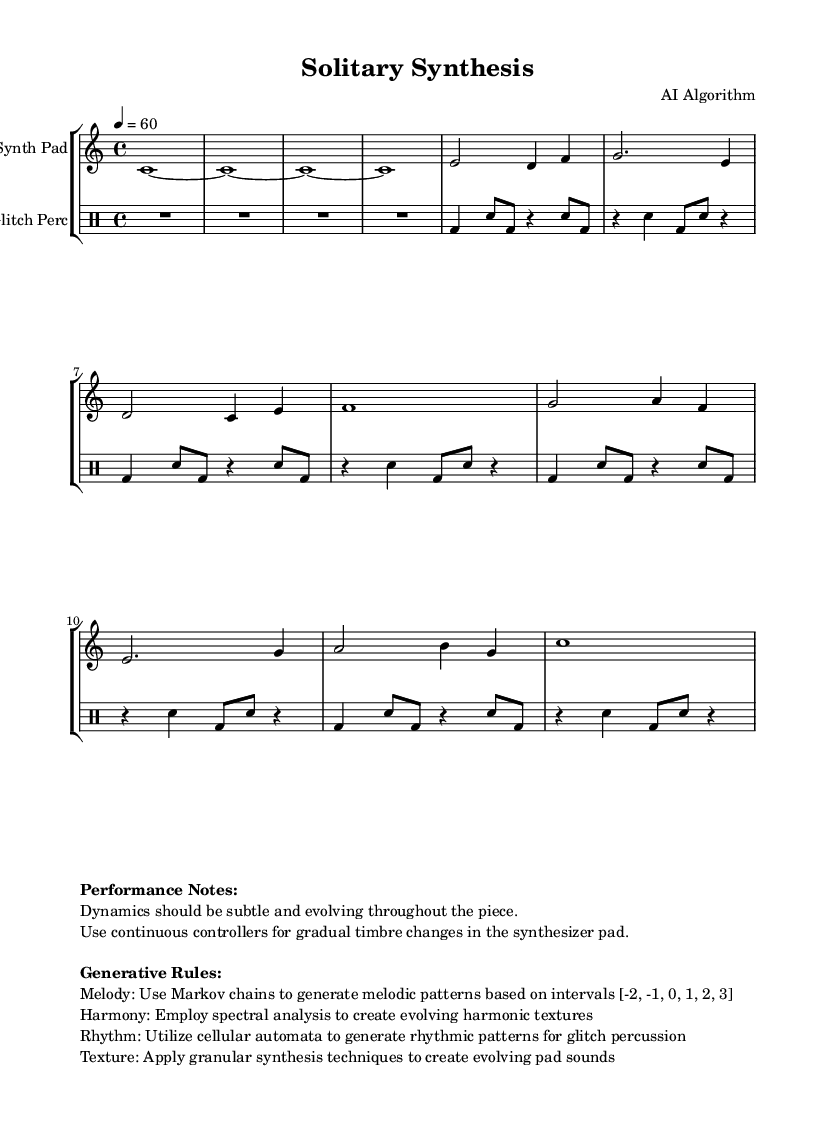What is the key signature of this music? The key signature is indicated at the beginning of the score. Here, it shows C major, which has no sharps or flats.
Answer: C major What is the time signature of this music? The time signature is found next to the key signature at the start of the score, represented as 4/4. This means there are four beats in each measure and a quarter note receives one beat.
Answer: 4/4 What is the tempo marking of the piece? The tempo is specified with the marking "4 = 60," meaning that each quarter note is to be played at a speed of 60 beats per minute. This provides a slow, steady pace for the performance.
Answer: 60 What dynamics are indicated for the performance? The performance notes specify that dynamics should be "subtle and evolving," suggesting a soft dynamic level which gradually changes throughout the piece.
Answer: Subtle and evolving How many measures are in Section A? Section A is described in the music, and by counting the measures from the provided melodic part, we can see it contains 8 measures.
Answer: 8 What type of synthesis technique is used for the pad sounds? The performance notes mention "granular synthesis techniques," which refers to a method of sound synthesis that utilizes small segments or grains of sound.
Answer: Granular synthesis How does the rhythm for glitch percussion get generated? The performance notes indicate the use of "cellular automata" to generate rhythmic patterns for the glitch percussion, which is a method of algorithmically producing patterns based on initial conditions and rules.
Answer: Cellular automata 